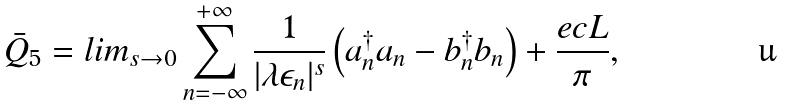Convert formula to latex. <formula><loc_0><loc_0><loc_500><loc_500>{ \bar { Q } } _ { 5 } = l i m _ { s \rightarrow 0 } \sum _ { n = - \infty } ^ { + \infty } \frac { 1 } { | \lambda \epsilon _ { n } | ^ { s } } \left ( { a } _ { n } ^ { \dagger } { a } _ { n } - { b } _ { n } ^ { \dagger } { b } _ { n } \right ) + \frac { e c L } { \pi } ,</formula> 